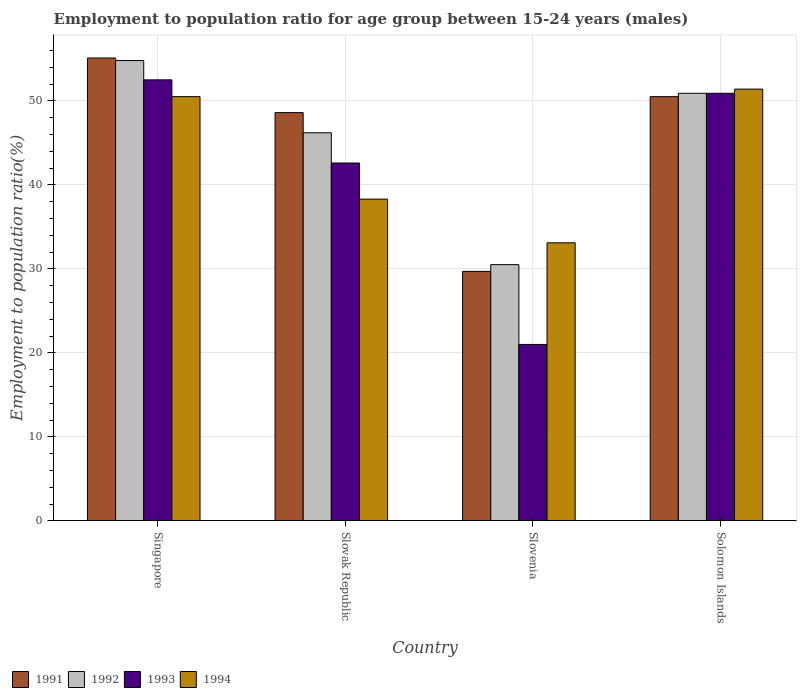How many different coloured bars are there?
Your answer should be compact. 4. How many bars are there on the 2nd tick from the left?
Your answer should be compact. 4. How many bars are there on the 4th tick from the right?
Your response must be concise. 4. What is the label of the 2nd group of bars from the left?
Your response must be concise. Slovak Republic. What is the employment to population ratio in 1994 in Solomon Islands?
Keep it short and to the point. 51.4. Across all countries, what is the maximum employment to population ratio in 1992?
Make the answer very short. 54.8. Across all countries, what is the minimum employment to population ratio in 1994?
Provide a short and direct response. 33.1. In which country was the employment to population ratio in 1993 maximum?
Provide a short and direct response. Singapore. In which country was the employment to population ratio in 1994 minimum?
Provide a short and direct response. Slovenia. What is the total employment to population ratio in 1994 in the graph?
Make the answer very short. 173.3. What is the difference between the employment to population ratio in 1992 in Singapore and that in Slovenia?
Your response must be concise. 24.3. What is the difference between the employment to population ratio in 1994 in Slovak Republic and the employment to population ratio in 1991 in Solomon Islands?
Offer a very short reply. -12.2. What is the average employment to population ratio in 1991 per country?
Ensure brevity in your answer.  45.97. What is the difference between the employment to population ratio of/in 1993 and employment to population ratio of/in 1994 in Slovenia?
Your answer should be compact. -12.1. In how many countries, is the employment to population ratio in 1994 greater than 32 %?
Keep it short and to the point. 4. What is the ratio of the employment to population ratio in 1991 in Singapore to that in Slovak Republic?
Your answer should be very brief. 1.13. Is the employment to population ratio in 1992 in Singapore less than that in Slovak Republic?
Make the answer very short. No. Is the difference between the employment to population ratio in 1993 in Slovak Republic and Slovenia greater than the difference between the employment to population ratio in 1994 in Slovak Republic and Slovenia?
Your response must be concise. Yes. What is the difference between the highest and the second highest employment to population ratio in 1993?
Ensure brevity in your answer.  -1.6. What is the difference between the highest and the lowest employment to population ratio in 1994?
Make the answer very short. 18.3. What does the 2nd bar from the left in Slovak Republic represents?
Your answer should be very brief. 1992. How many bars are there?
Your answer should be compact. 16. What is the difference between two consecutive major ticks on the Y-axis?
Your answer should be compact. 10. Does the graph contain grids?
Give a very brief answer. Yes. How are the legend labels stacked?
Offer a very short reply. Horizontal. What is the title of the graph?
Ensure brevity in your answer.  Employment to population ratio for age group between 15-24 years (males). Does "1992" appear as one of the legend labels in the graph?
Provide a short and direct response. Yes. What is the Employment to population ratio(%) of 1991 in Singapore?
Offer a terse response. 55.1. What is the Employment to population ratio(%) in 1992 in Singapore?
Your response must be concise. 54.8. What is the Employment to population ratio(%) in 1993 in Singapore?
Provide a succinct answer. 52.5. What is the Employment to population ratio(%) in 1994 in Singapore?
Provide a succinct answer. 50.5. What is the Employment to population ratio(%) of 1991 in Slovak Republic?
Make the answer very short. 48.6. What is the Employment to population ratio(%) of 1992 in Slovak Republic?
Provide a succinct answer. 46.2. What is the Employment to population ratio(%) in 1993 in Slovak Republic?
Your answer should be very brief. 42.6. What is the Employment to population ratio(%) of 1994 in Slovak Republic?
Give a very brief answer. 38.3. What is the Employment to population ratio(%) in 1991 in Slovenia?
Provide a succinct answer. 29.7. What is the Employment to population ratio(%) of 1992 in Slovenia?
Your answer should be compact. 30.5. What is the Employment to population ratio(%) of 1994 in Slovenia?
Keep it short and to the point. 33.1. What is the Employment to population ratio(%) of 1991 in Solomon Islands?
Keep it short and to the point. 50.5. What is the Employment to population ratio(%) in 1992 in Solomon Islands?
Provide a short and direct response. 50.9. What is the Employment to population ratio(%) of 1993 in Solomon Islands?
Your response must be concise. 50.9. What is the Employment to population ratio(%) of 1994 in Solomon Islands?
Ensure brevity in your answer.  51.4. Across all countries, what is the maximum Employment to population ratio(%) of 1991?
Provide a short and direct response. 55.1. Across all countries, what is the maximum Employment to population ratio(%) in 1992?
Ensure brevity in your answer.  54.8. Across all countries, what is the maximum Employment to population ratio(%) of 1993?
Provide a succinct answer. 52.5. Across all countries, what is the maximum Employment to population ratio(%) in 1994?
Your answer should be compact. 51.4. Across all countries, what is the minimum Employment to population ratio(%) of 1991?
Your answer should be compact. 29.7. Across all countries, what is the minimum Employment to population ratio(%) of 1992?
Make the answer very short. 30.5. Across all countries, what is the minimum Employment to population ratio(%) in 1994?
Your answer should be compact. 33.1. What is the total Employment to population ratio(%) of 1991 in the graph?
Offer a terse response. 183.9. What is the total Employment to population ratio(%) of 1992 in the graph?
Your response must be concise. 182.4. What is the total Employment to population ratio(%) of 1993 in the graph?
Make the answer very short. 167. What is the total Employment to population ratio(%) of 1994 in the graph?
Make the answer very short. 173.3. What is the difference between the Employment to population ratio(%) of 1994 in Singapore and that in Slovak Republic?
Your answer should be very brief. 12.2. What is the difference between the Employment to population ratio(%) in 1991 in Singapore and that in Slovenia?
Offer a very short reply. 25.4. What is the difference between the Employment to population ratio(%) in 1992 in Singapore and that in Slovenia?
Offer a terse response. 24.3. What is the difference between the Employment to population ratio(%) in 1993 in Singapore and that in Slovenia?
Your answer should be very brief. 31.5. What is the difference between the Employment to population ratio(%) of 1992 in Slovak Republic and that in Slovenia?
Keep it short and to the point. 15.7. What is the difference between the Employment to population ratio(%) of 1993 in Slovak Republic and that in Slovenia?
Keep it short and to the point. 21.6. What is the difference between the Employment to population ratio(%) of 1991 in Slovenia and that in Solomon Islands?
Provide a succinct answer. -20.8. What is the difference between the Employment to population ratio(%) in 1992 in Slovenia and that in Solomon Islands?
Provide a short and direct response. -20.4. What is the difference between the Employment to population ratio(%) of 1993 in Slovenia and that in Solomon Islands?
Your answer should be compact. -29.9. What is the difference between the Employment to population ratio(%) of 1994 in Slovenia and that in Solomon Islands?
Your answer should be compact. -18.3. What is the difference between the Employment to population ratio(%) in 1991 in Singapore and the Employment to population ratio(%) in 1992 in Slovak Republic?
Offer a very short reply. 8.9. What is the difference between the Employment to population ratio(%) of 1992 in Singapore and the Employment to population ratio(%) of 1994 in Slovak Republic?
Give a very brief answer. 16.5. What is the difference between the Employment to population ratio(%) of 1993 in Singapore and the Employment to population ratio(%) of 1994 in Slovak Republic?
Ensure brevity in your answer.  14.2. What is the difference between the Employment to population ratio(%) in 1991 in Singapore and the Employment to population ratio(%) in 1992 in Slovenia?
Ensure brevity in your answer.  24.6. What is the difference between the Employment to population ratio(%) of 1991 in Singapore and the Employment to population ratio(%) of 1993 in Slovenia?
Give a very brief answer. 34.1. What is the difference between the Employment to population ratio(%) of 1991 in Singapore and the Employment to population ratio(%) of 1994 in Slovenia?
Your answer should be compact. 22. What is the difference between the Employment to population ratio(%) in 1992 in Singapore and the Employment to population ratio(%) in 1993 in Slovenia?
Ensure brevity in your answer.  33.8. What is the difference between the Employment to population ratio(%) in 1992 in Singapore and the Employment to population ratio(%) in 1994 in Slovenia?
Keep it short and to the point. 21.7. What is the difference between the Employment to population ratio(%) in 1993 in Singapore and the Employment to population ratio(%) in 1994 in Slovenia?
Provide a short and direct response. 19.4. What is the difference between the Employment to population ratio(%) in 1991 in Singapore and the Employment to population ratio(%) in 1992 in Solomon Islands?
Keep it short and to the point. 4.2. What is the difference between the Employment to population ratio(%) of 1992 in Singapore and the Employment to population ratio(%) of 1994 in Solomon Islands?
Keep it short and to the point. 3.4. What is the difference between the Employment to population ratio(%) of 1991 in Slovak Republic and the Employment to population ratio(%) of 1992 in Slovenia?
Provide a short and direct response. 18.1. What is the difference between the Employment to population ratio(%) in 1991 in Slovak Republic and the Employment to population ratio(%) in 1993 in Slovenia?
Ensure brevity in your answer.  27.6. What is the difference between the Employment to population ratio(%) of 1991 in Slovak Republic and the Employment to population ratio(%) of 1994 in Slovenia?
Your answer should be very brief. 15.5. What is the difference between the Employment to population ratio(%) of 1992 in Slovak Republic and the Employment to population ratio(%) of 1993 in Slovenia?
Give a very brief answer. 25.2. What is the difference between the Employment to population ratio(%) in 1993 in Slovak Republic and the Employment to population ratio(%) in 1994 in Slovenia?
Offer a very short reply. 9.5. What is the difference between the Employment to population ratio(%) of 1991 in Slovak Republic and the Employment to population ratio(%) of 1993 in Solomon Islands?
Your answer should be compact. -2.3. What is the difference between the Employment to population ratio(%) in 1991 in Slovak Republic and the Employment to population ratio(%) in 1994 in Solomon Islands?
Provide a short and direct response. -2.8. What is the difference between the Employment to population ratio(%) in 1992 in Slovak Republic and the Employment to population ratio(%) in 1993 in Solomon Islands?
Make the answer very short. -4.7. What is the difference between the Employment to population ratio(%) of 1993 in Slovak Republic and the Employment to population ratio(%) of 1994 in Solomon Islands?
Your response must be concise. -8.8. What is the difference between the Employment to population ratio(%) in 1991 in Slovenia and the Employment to population ratio(%) in 1992 in Solomon Islands?
Offer a very short reply. -21.2. What is the difference between the Employment to population ratio(%) of 1991 in Slovenia and the Employment to population ratio(%) of 1993 in Solomon Islands?
Provide a short and direct response. -21.2. What is the difference between the Employment to population ratio(%) of 1991 in Slovenia and the Employment to population ratio(%) of 1994 in Solomon Islands?
Your response must be concise. -21.7. What is the difference between the Employment to population ratio(%) of 1992 in Slovenia and the Employment to population ratio(%) of 1993 in Solomon Islands?
Provide a short and direct response. -20.4. What is the difference between the Employment to population ratio(%) of 1992 in Slovenia and the Employment to population ratio(%) of 1994 in Solomon Islands?
Your answer should be compact. -20.9. What is the difference between the Employment to population ratio(%) in 1993 in Slovenia and the Employment to population ratio(%) in 1994 in Solomon Islands?
Give a very brief answer. -30.4. What is the average Employment to population ratio(%) in 1991 per country?
Provide a succinct answer. 45.98. What is the average Employment to population ratio(%) of 1992 per country?
Make the answer very short. 45.6. What is the average Employment to population ratio(%) in 1993 per country?
Ensure brevity in your answer.  41.75. What is the average Employment to population ratio(%) in 1994 per country?
Provide a short and direct response. 43.33. What is the difference between the Employment to population ratio(%) of 1991 and Employment to population ratio(%) of 1993 in Singapore?
Ensure brevity in your answer.  2.6. What is the difference between the Employment to population ratio(%) of 1992 and Employment to population ratio(%) of 1993 in Singapore?
Your response must be concise. 2.3. What is the difference between the Employment to population ratio(%) of 1992 and Employment to population ratio(%) of 1994 in Singapore?
Provide a short and direct response. 4.3. What is the difference between the Employment to population ratio(%) of 1993 and Employment to population ratio(%) of 1994 in Singapore?
Make the answer very short. 2. What is the difference between the Employment to population ratio(%) in 1991 and Employment to population ratio(%) in 1994 in Slovak Republic?
Provide a short and direct response. 10.3. What is the difference between the Employment to population ratio(%) in 1992 and Employment to population ratio(%) in 1994 in Slovak Republic?
Provide a succinct answer. 7.9. What is the difference between the Employment to population ratio(%) in 1991 and Employment to population ratio(%) in 1992 in Slovenia?
Ensure brevity in your answer.  -0.8. What is the difference between the Employment to population ratio(%) of 1991 and Employment to population ratio(%) of 1993 in Slovenia?
Your answer should be compact. 8.7. What is the difference between the Employment to population ratio(%) in 1992 and Employment to population ratio(%) in 1993 in Slovenia?
Give a very brief answer. 9.5. What is the difference between the Employment to population ratio(%) in 1993 and Employment to population ratio(%) in 1994 in Slovenia?
Keep it short and to the point. -12.1. What is the difference between the Employment to population ratio(%) in 1991 and Employment to population ratio(%) in 1993 in Solomon Islands?
Make the answer very short. -0.4. What is the difference between the Employment to population ratio(%) in 1992 and Employment to population ratio(%) in 1993 in Solomon Islands?
Your answer should be compact. 0. What is the difference between the Employment to population ratio(%) in 1993 and Employment to population ratio(%) in 1994 in Solomon Islands?
Your response must be concise. -0.5. What is the ratio of the Employment to population ratio(%) in 1991 in Singapore to that in Slovak Republic?
Provide a short and direct response. 1.13. What is the ratio of the Employment to population ratio(%) in 1992 in Singapore to that in Slovak Republic?
Provide a short and direct response. 1.19. What is the ratio of the Employment to population ratio(%) of 1993 in Singapore to that in Slovak Republic?
Your answer should be very brief. 1.23. What is the ratio of the Employment to population ratio(%) of 1994 in Singapore to that in Slovak Republic?
Ensure brevity in your answer.  1.32. What is the ratio of the Employment to population ratio(%) in 1991 in Singapore to that in Slovenia?
Give a very brief answer. 1.86. What is the ratio of the Employment to population ratio(%) in 1992 in Singapore to that in Slovenia?
Give a very brief answer. 1.8. What is the ratio of the Employment to population ratio(%) of 1993 in Singapore to that in Slovenia?
Provide a short and direct response. 2.5. What is the ratio of the Employment to population ratio(%) in 1994 in Singapore to that in Slovenia?
Offer a very short reply. 1.53. What is the ratio of the Employment to population ratio(%) of 1991 in Singapore to that in Solomon Islands?
Provide a short and direct response. 1.09. What is the ratio of the Employment to population ratio(%) of 1992 in Singapore to that in Solomon Islands?
Provide a succinct answer. 1.08. What is the ratio of the Employment to population ratio(%) of 1993 in Singapore to that in Solomon Islands?
Provide a short and direct response. 1.03. What is the ratio of the Employment to population ratio(%) of 1994 in Singapore to that in Solomon Islands?
Give a very brief answer. 0.98. What is the ratio of the Employment to population ratio(%) of 1991 in Slovak Republic to that in Slovenia?
Make the answer very short. 1.64. What is the ratio of the Employment to population ratio(%) in 1992 in Slovak Republic to that in Slovenia?
Provide a short and direct response. 1.51. What is the ratio of the Employment to population ratio(%) of 1993 in Slovak Republic to that in Slovenia?
Ensure brevity in your answer.  2.03. What is the ratio of the Employment to population ratio(%) of 1994 in Slovak Republic to that in Slovenia?
Ensure brevity in your answer.  1.16. What is the ratio of the Employment to population ratio(%) of 1991 in Slovak Republic to that in Solomon Islands?
Offer a very short reply. 0.96. What is the ratio of the Employment to population ratio(%) in 1992 in Slovak Republic to that in Solomon Islands?
Make the answer very short. 0.91. What is the ratio of the Employment to population ratio(%) of 1993 in Slovak Republic to that in Solomon Islands?
Provide a succinct answer. 0.84. What is the ratio of the Employment to population ratio(%) in 1994 in Slovak Republic to that in Solomon Islands?
Offer a very short reply. 0.75. What is the ratio of the Employment to population ratio(%) of 1991 in Slovenia to that in Solomon Islands?
Keep it short and to the point. 0.59. What is the ratio of the Employment to population ratio(%) in 1992 in Slovenia to that in Solomon Islands?
Offer a very short reply. 0.6. What is the ratio of the Employment to population ratio(%) of 1993 in Slovenia to that in Solomon Islands?
Keep it short and to the point. 0.41. What is the ratio of the Employment to population ratio(%) in 1994 in Slovenia to that in Solomon Islands?
Provide a succinct answer. 0.64. What is the difference between the highest and the lowest Employment to population ratio(%) of 1991?
Your answer should be very brief. 25.4. What is the difference between the highest and the lowest Employment to population ratio(%) in 1992?
Provide a short and direct response. 24.3. What is the difference between the highest and the lowest Employment to population ratio(%) in 1993?
Your answer should be compact. 31.5. 